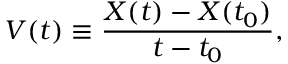Convert formula to latex. <formula><loc_0><loc_0><loc_500><loc_500>V ( t ) \equiv \frac { X ( t ) - X ( t _ { 0 } ) } { t - t _ { 0 } } ,</formula> 